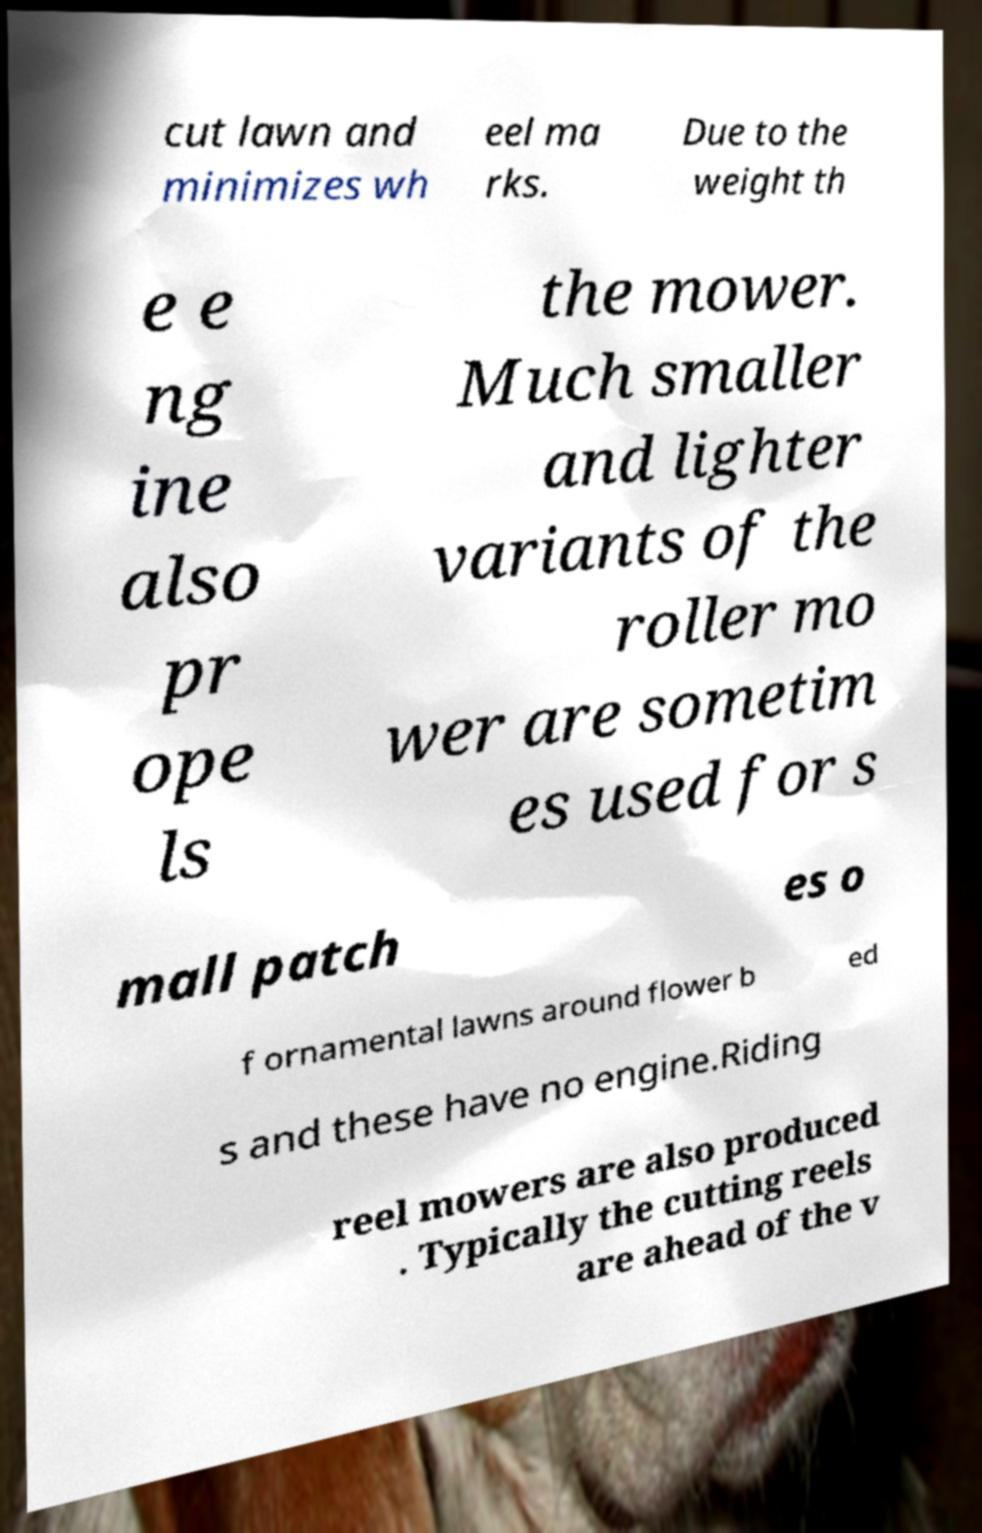Could you extract and type out the text from this image? cut lawn and minimizes wh eel ma rks. Due to the weight th e e ng ine also pr ope ls the mower. Much smaller and lighter variants of the roller mo wer are sometim es used for s mall patch es o f ornamental lawns around flower b ed s and these have no engine.Riding reel mowers are also produced . Typically the cutting reels are ahead of the v 